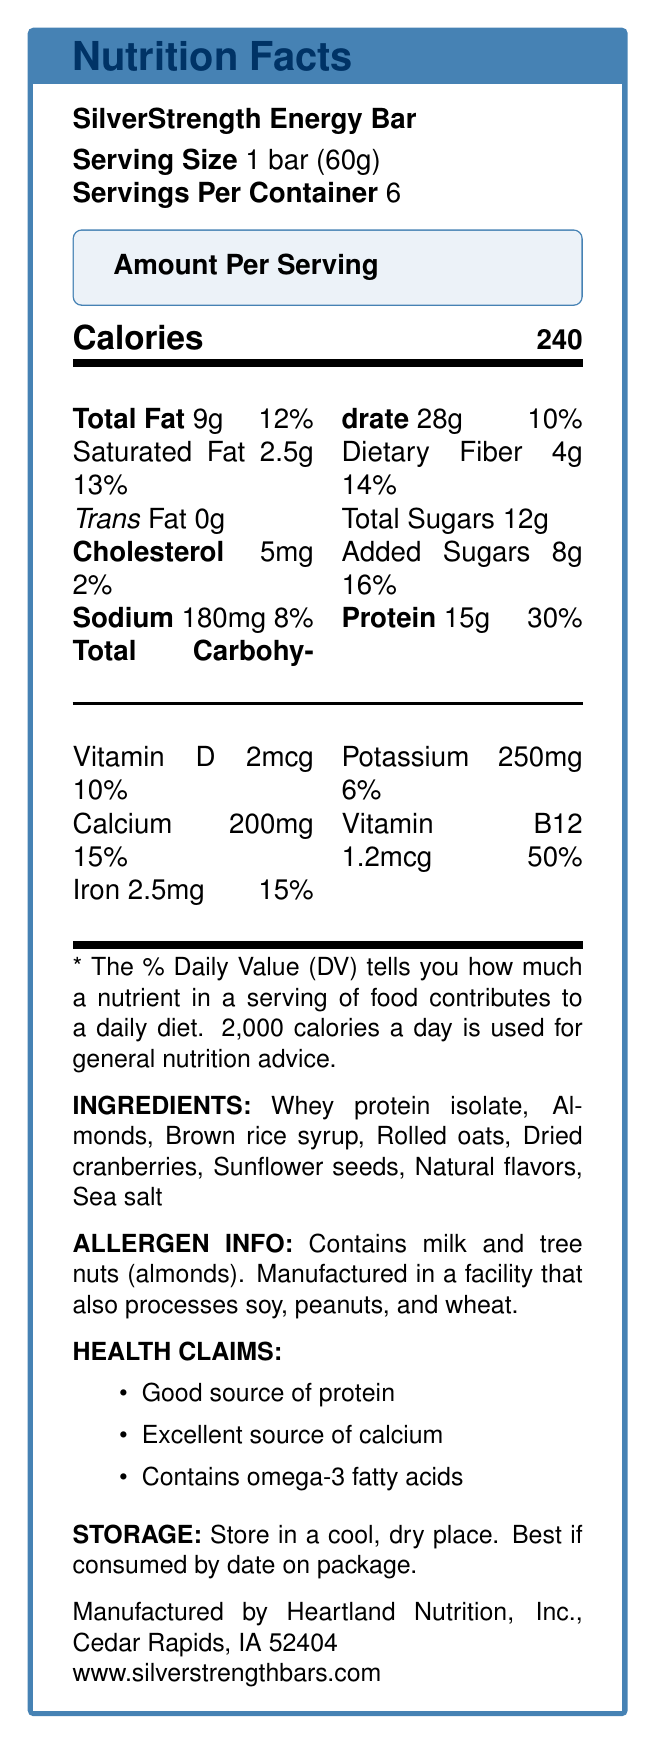how many servings are in one container? The document states that there are 6 servings per container.
Answer: 6 how much protein is in one serving? The document indicates that one serving contains 15g of protein.
Answer: 15g what is the percentage daily value of calcium provided by one serving? The document shows that one serving provides 15% of the daily value for calcium.
Answer: 15% what allergens are mentioned in this product? The allergen information in the document lists milk and tree nuts (almonds) as allergens.
Answer: milk and tree nuts (almonds) who manufactures the SilverStrength Energy Bar? According to the document, SilverStrength Energy Bar is manufactured by Heartland Nutrition, Inc., Cedar Rapids, IA 52404.
Answer: Heartland Nutrition, Inc. how many grams of dietary fiber are in each serving? The document states that each serving contains 4g of dietary fiber.
Answer: 4g What is the total percentage of daily value for added sugars? The document notes that added sugars account for 16% of the daily value.
Answer: 16% where should you store the SilverStrength Energy Bar? A. Refrigerator B. Cool, dry place C. Freezer D. Warm cupboard The storage instructions in the document state that the product should be stored in a cool, dry place.
Answer: B which of the following nutrients has the highest daily value percentage per serving? A. Protein B. Calcium C. Vitamin B12 D. Iron The document indicates that Vitamin B12 has the highest daily value percentage per serving at 50%.
Answer: C true or false: The SilverStrength Energy Bar contains peanuts. According to the allergen information, the bar does not contain peanuts but is manufactured in a facility that processes peanuts.
Answer: False summarize the main idea of the Nutrition Facts Label for the SilverStrength Energy Bar. The document provides information on serving size, nutritional content, allergen information, health claims, and storage instructions for the SilverStrength Energy Bar manufactured by Heartland Nutrition, Inc.
Answer: The SilverStrength Energy Bar is a high-protein energy bar aimed at active seniors. It contains significant amounts of protein, calcium, and Vitamin B12, with a balanced mix of fats, carbohydrates, and dietary fibers per 60g serving. The bar contains milk and almonds, and should be stored in a cool, dry place. how many milligrams of Vitamin C are in a serving of SilverStrength Energy Bar? The document does not provide any information regarding Vitamin C.
Answer: Not enough information how many calories are in one serving? The document clearly states that each serving contains 240 calories.
Answer: 240 what is the daily value percentage for total fat per serving? The document notes that the daily value percentage for total fat per serving is 12%.
Answer: 12% 